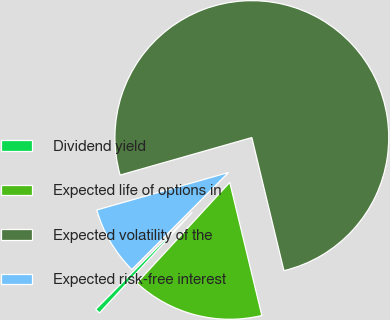Convert chart to OTSL. <chart><loc_0><loc_0><loc_500><loc_500><pie_chart><fcel>Dividend yield<fcel>Expected life of options in<fcel>Expected volatility of the<fcel>Expected risk-free interest<nl><fcel>0.61%<fcel>15.62%<fcel>75.65%<fcel>8.12%<nl></chart> 